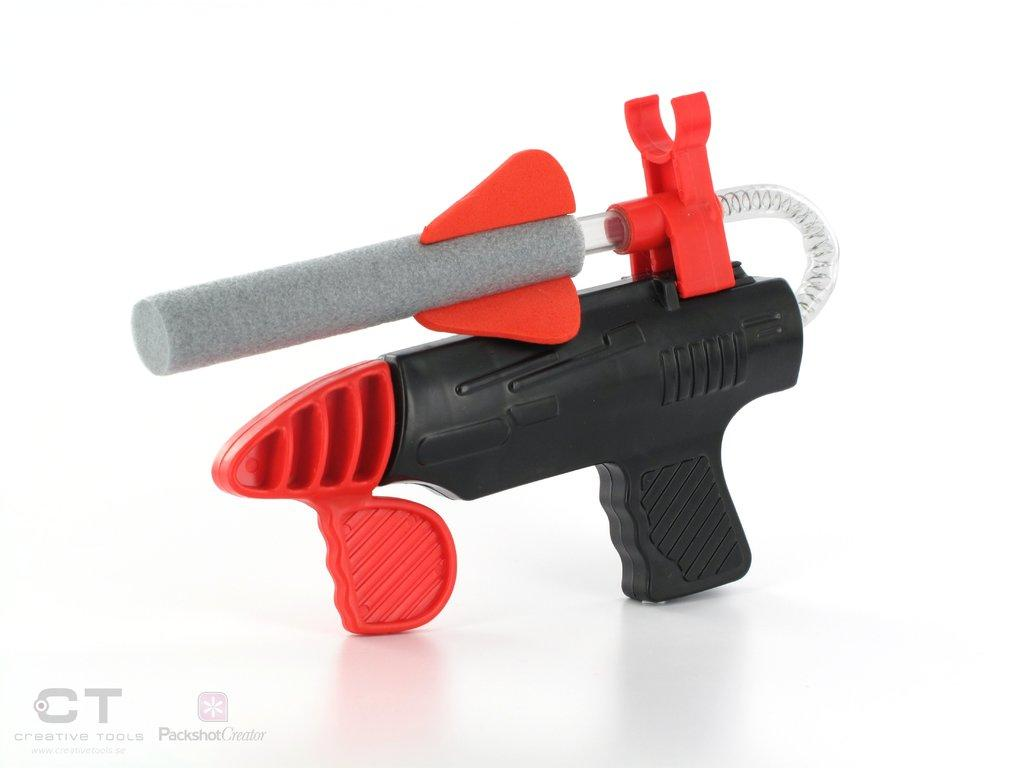What object can be seen in the image? There is a toy in the image. What language is the toy speaking in the image? Toys do not speak, so there is no language present in the image. What shape is the toy in the image? The provided facts do not mention the shape of the toy, so it cannot be determined from the image. 